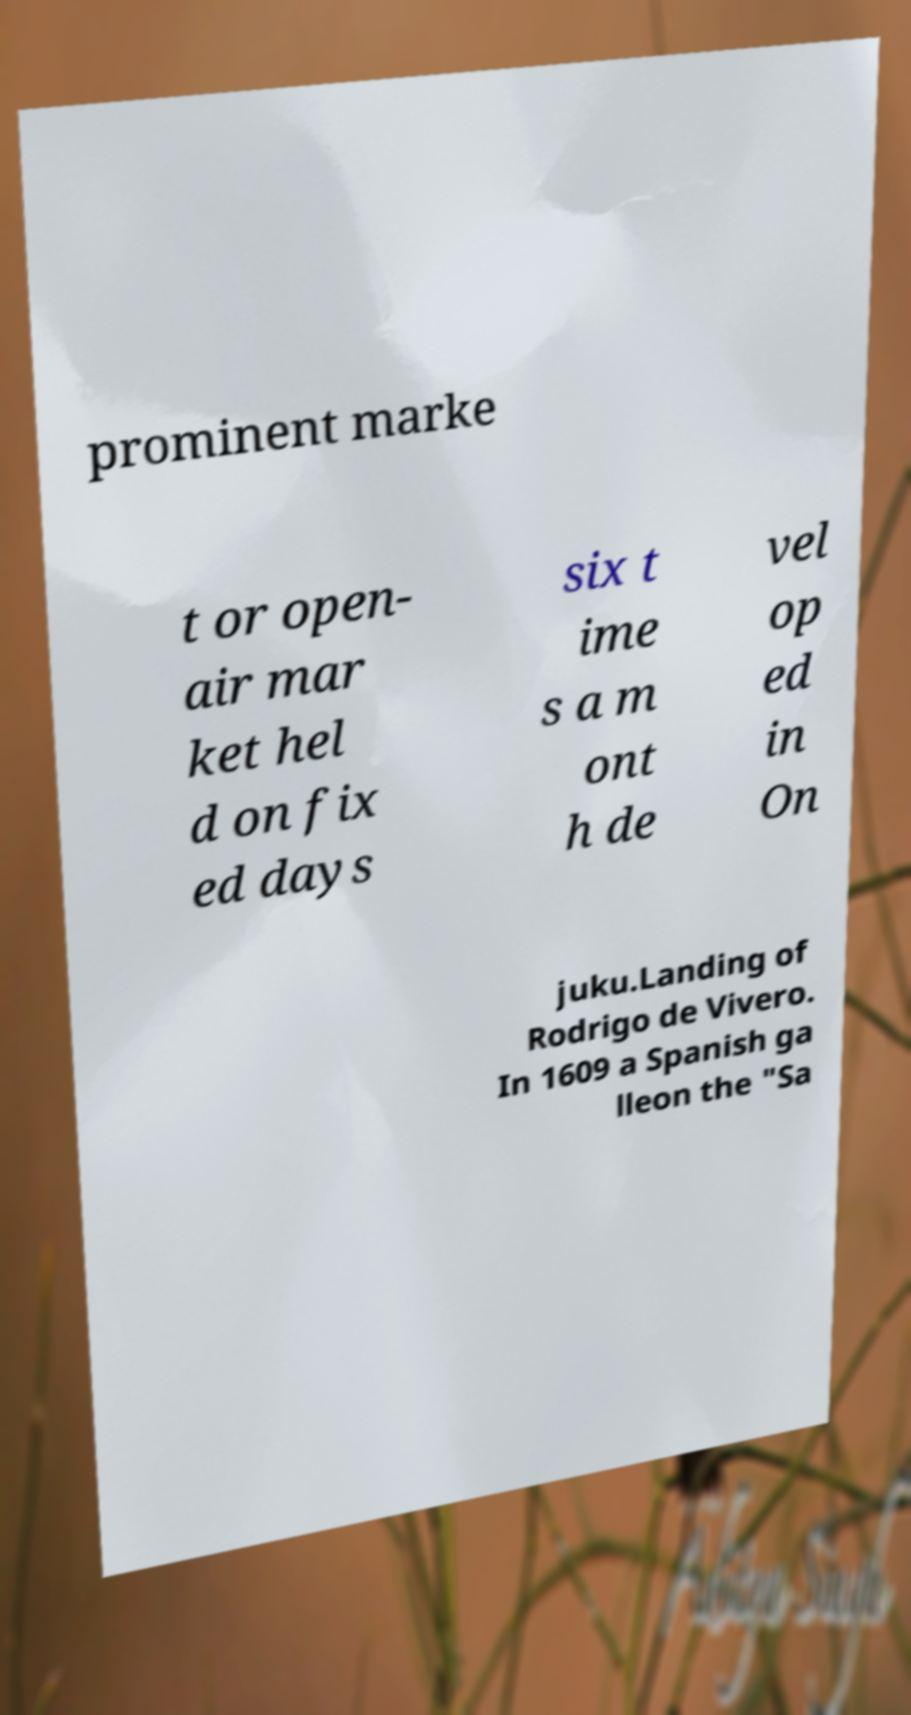I need the written content from this picture converted into text. Can you do that? prominent marke t or open- air mar ket hel d on fix ed days six t ime s a m ont h de vel op ed in On juku.Landing of Rodrigo de Vivero. In 1609 a Spanish ga lleon the "Sa 